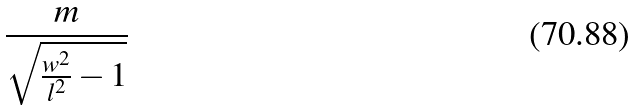Convert formula to latex. <formula><loc_0><loc_0><loc_500><loc_500>\frac { m } { \sqrt { \frac { w ^ { 2 } } { l ^ { 2 } } - 1 } }</formula> 